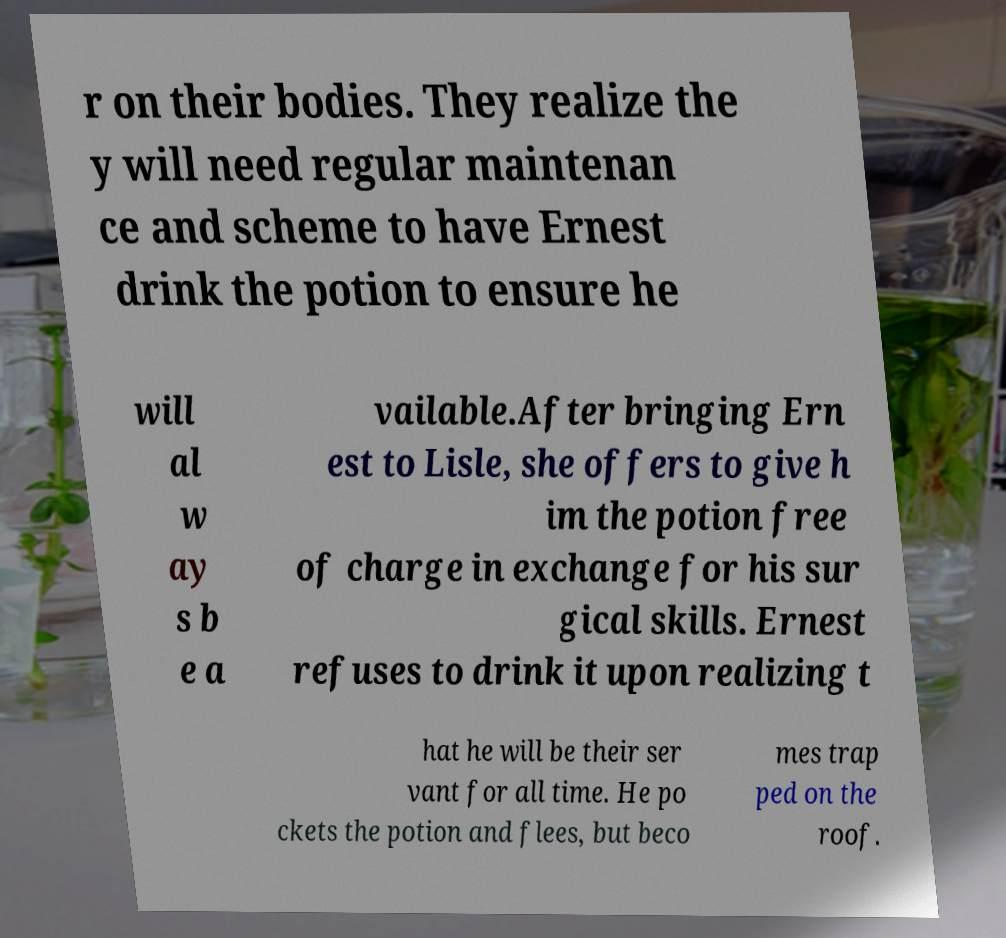Can you accurately transcribe the text from the provided image for me? r on their bodies. They realize the y will need regular maintenan ce and scheme to have Ernest drink the potion to ensure he will al w ay s b e a vailable.After bringing Ern est to Lisle, she offers to give h im the potion free of charge in exchange for his sur gical skills. Ernest refuses to drink it upon realizing t hat he will be their ser vant for all time. He po ckets the potion and flees, but beco mes trap ped on the roof. 